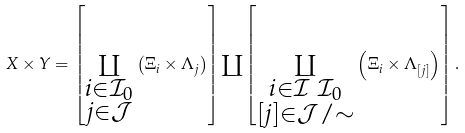<formula> <loc_0><loc_0><loc_500><loc_500>X \times Y = \left [ \coprod _ { \substack { i \in \mathcal { I } _ { 0 } \\ j \in \mathcal { J } } } \left ( \Xi _ { i } \times \Lambda _ { j } \right ) \right ] \coprod \left [ \coprod _ { \substack { i \in \mathcal { I } \ \mathcal { I } _ { 0 } \\ [ j ] \in \mathcal { J } / \sim } } \left ( \Xi _ { i } \times \Lambda _ { [ j ] } \right ) \right ] .</formula> 